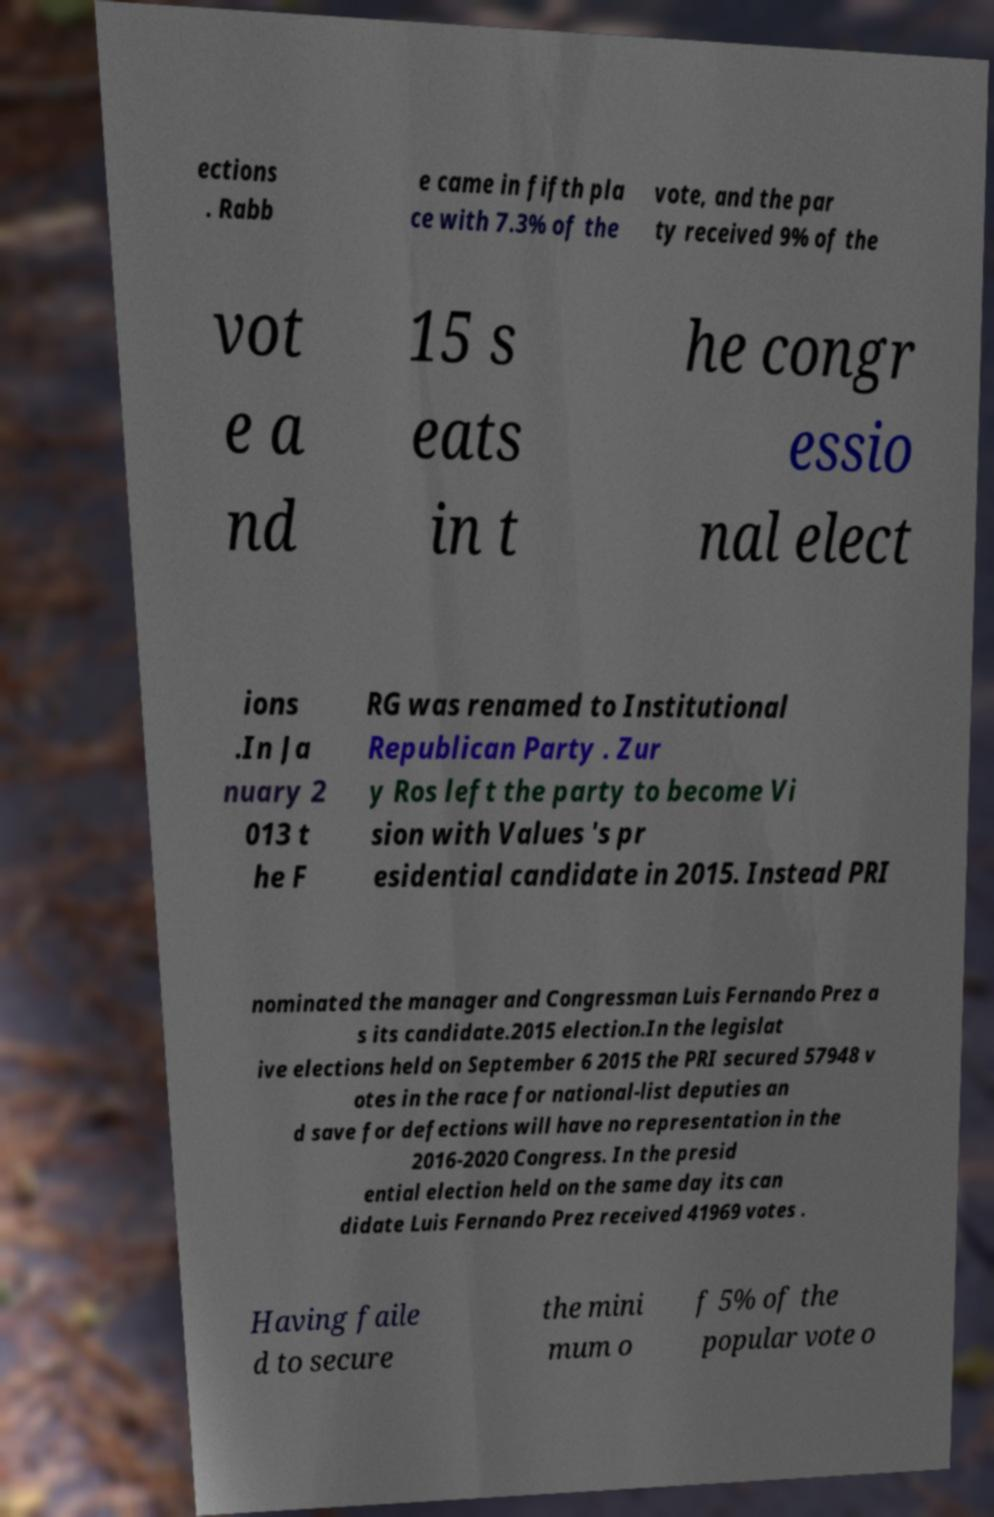Please read and relay the text visible in this image. What does it say? ections . Rabb e came in fifth pla ce with 7.3% of the vote, and the par ty received 9% of the vot e a nd 15 s eats in t he congr essio nal elect ions .In Ja nuary 2 013 t he F RG was renamed to Institutional Republican Party . Zur y Ros left the party to become Vi sion with Values 's pr esidential candidate in 2015. Instead PRI nominated the manager and Congressman Luis Fernando Prez a s its candidate.2015 election.In the legislat ive elections held on September 6 2015 the PRI secured 57948 v otes in the race for national-list deputies an d save for defections will have no representation in the 2016-2020 Congress. In the presid ential election held on the same day its can didate Luis Fernando Prez received 41969 votes . Having faile d to secure the mini mum o f 5% of the popular vote o 